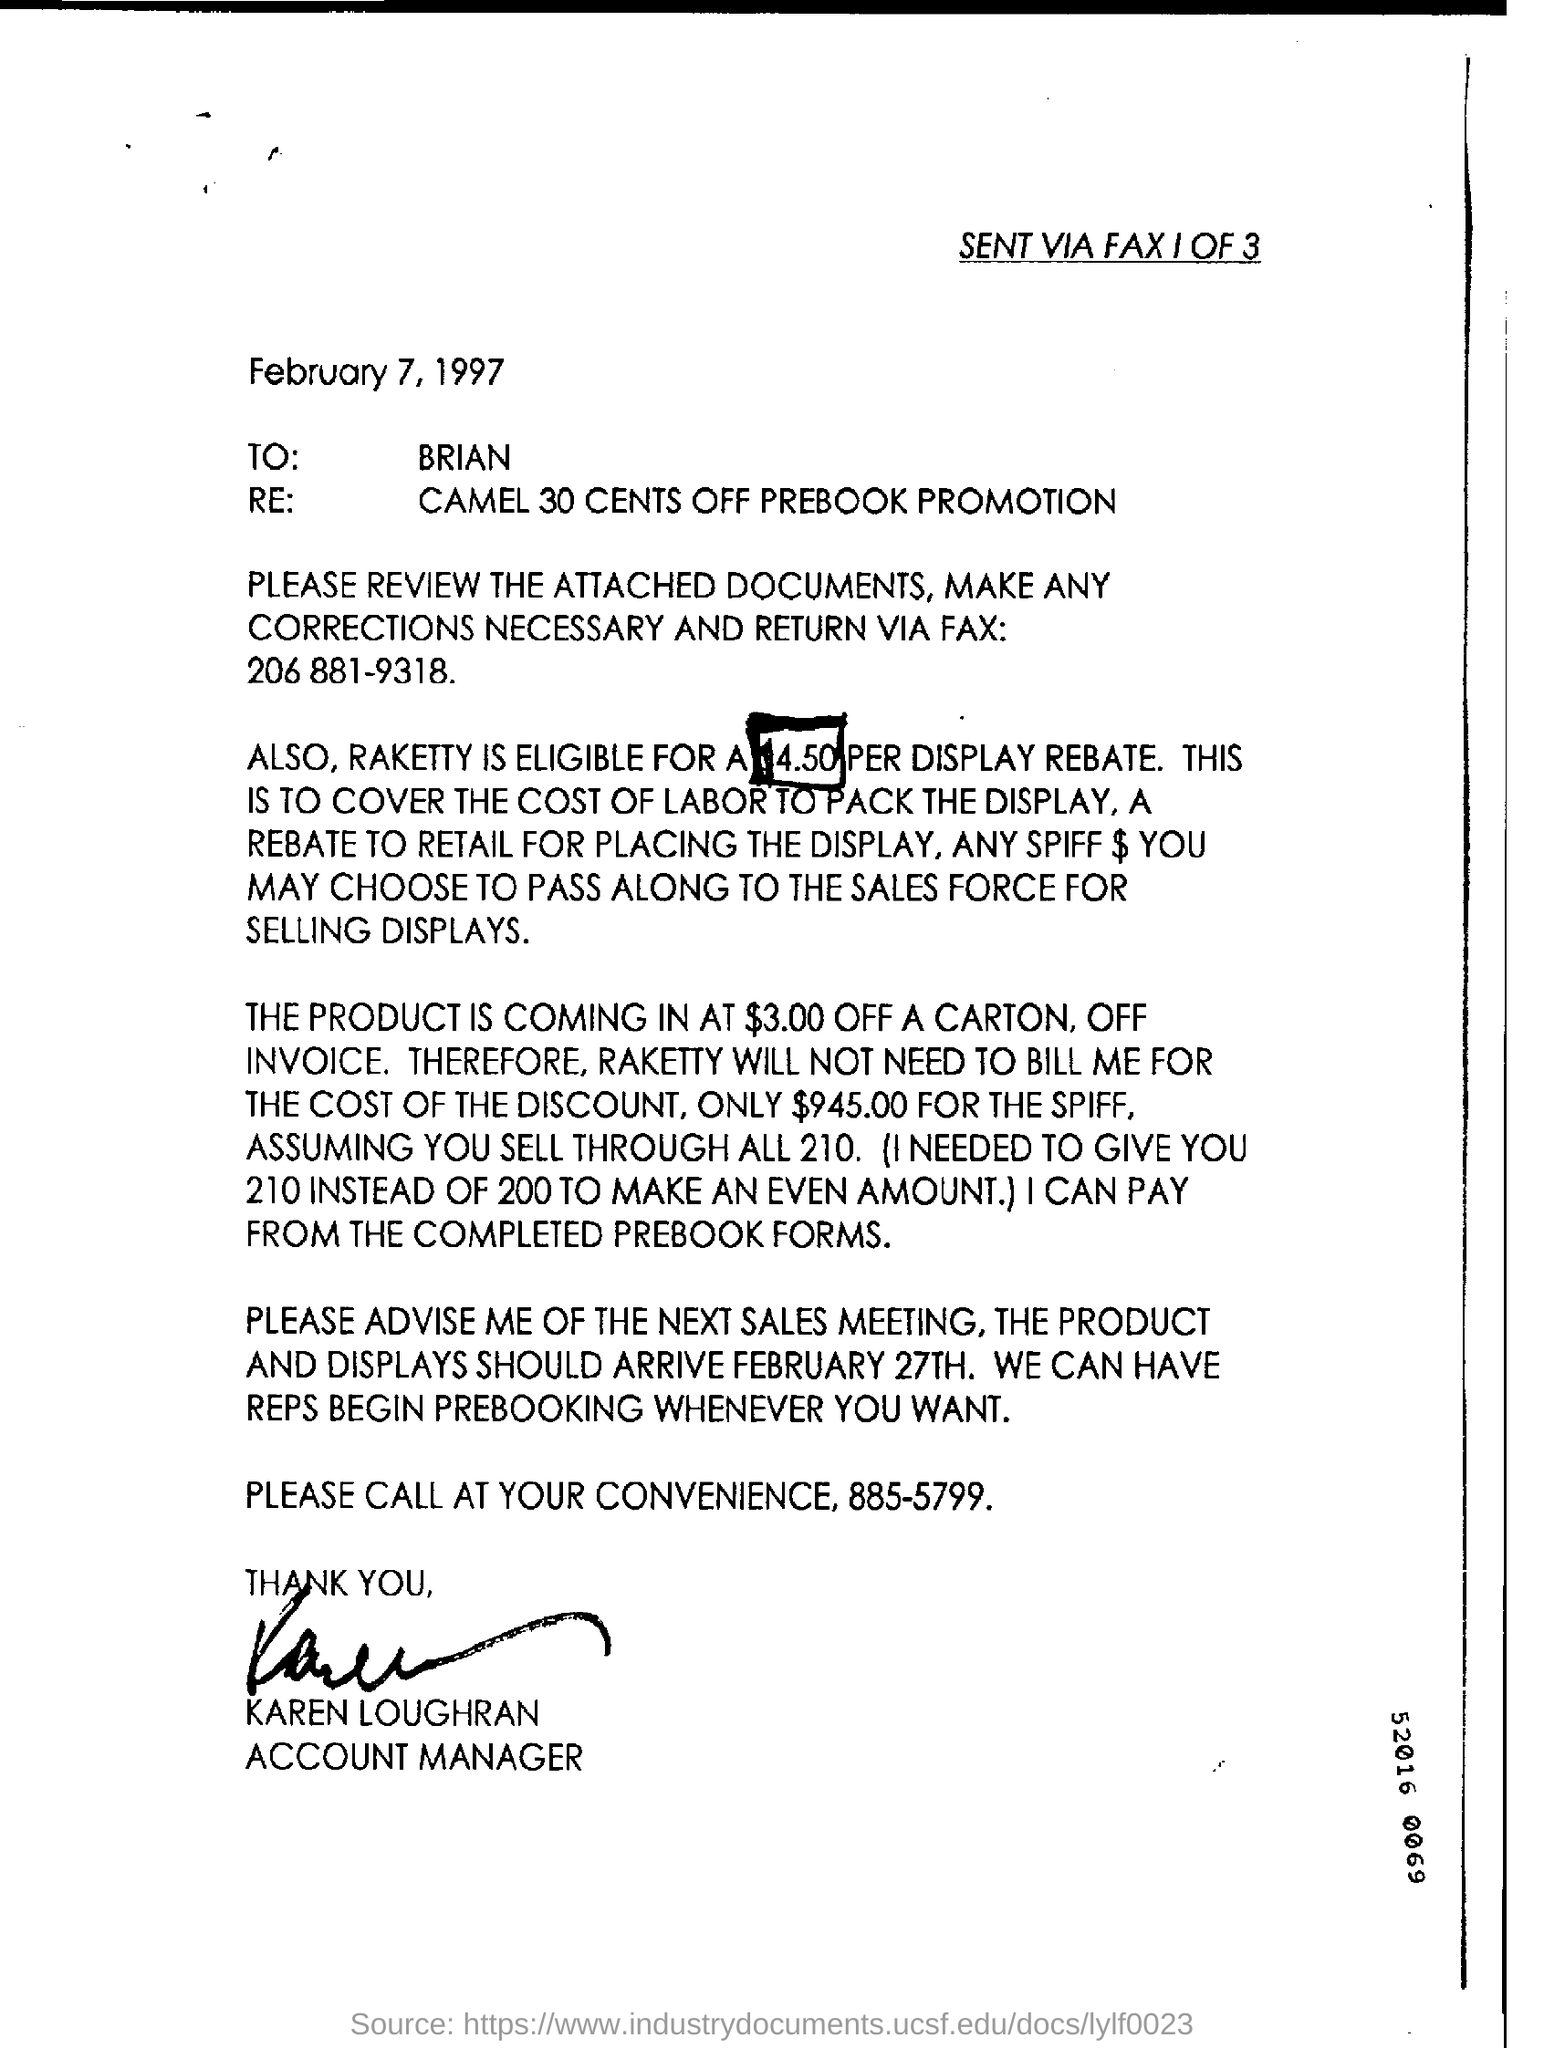What is the date mention in this document?
Offer a terse response. February 7,1997. What  is the fax number in the document ?
Keep it short and to the point. 206 881-9318. 